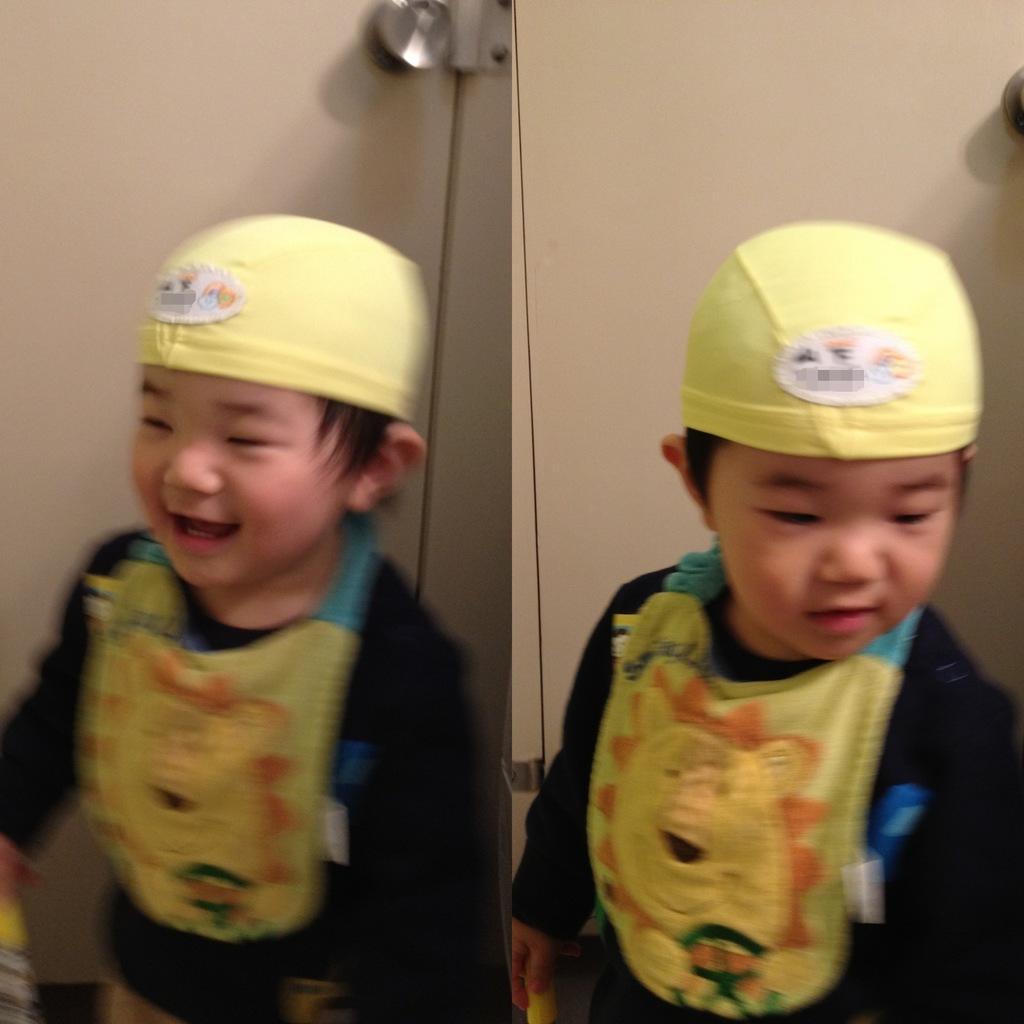Describe this image in one or two sentences. This picture is a collage of two images. In these two images I can observe a boy standing on the floor. He is wearing yellow color cap on his head. In the background I can observe door. 